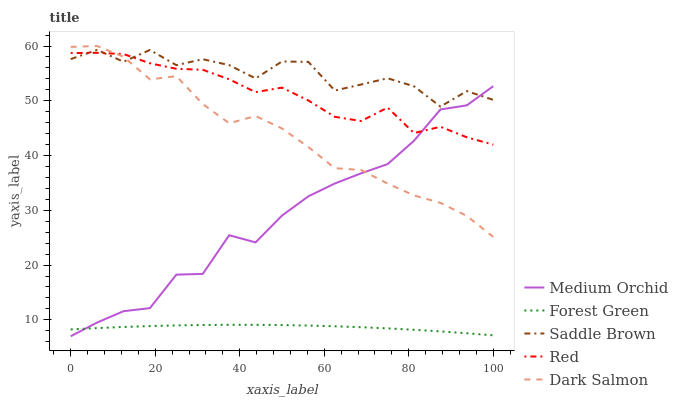Does Forest Green have the minimum area under the curve?
Answer yes or no. Yes. Does Saddle Brown have the maximum area under the curve?
Answer yes or no. Yes. Does Medium Orchid have the minimum area under the curve?
Answer yes or no. No. Does Medium Orchid have the maximum area under the curve?
Answer yes or no. No. Is Forest Green the smoothest?
Answer yes or no. Yes. Is Saddle Brown the roughest?
Answer yes or no. Yes. Is Medium Orchid the smoothest?
Answer yes or no. No. Is Medium Orchid the roughest?
Answer yes or no. No. Does Medium Orchid have the lowest value?
Answer yes or no. Yes. Does Saddle Brown have the lowest value?
Answer yes or no. No. Does Dark Salmon have the highest value?
Answer yes or no. Yes. Does Medium Orchid have the highest value?
Answer yes or no. No. Is Forest Green less than Red?
Answer yes or no. Yes. Is Dark Salmon greater than Forest Green?
Answer yes or no. Yes. Does Red intersect Medium Orchid?
Answer yes or no. Yes. Is Red less than Medium Orchid?
Answer yes or no. No. Is Red greater than Medium Orchid?
Answer yes or no. No. Does Forest Green intersect Red?
Answer yes or no. No. 